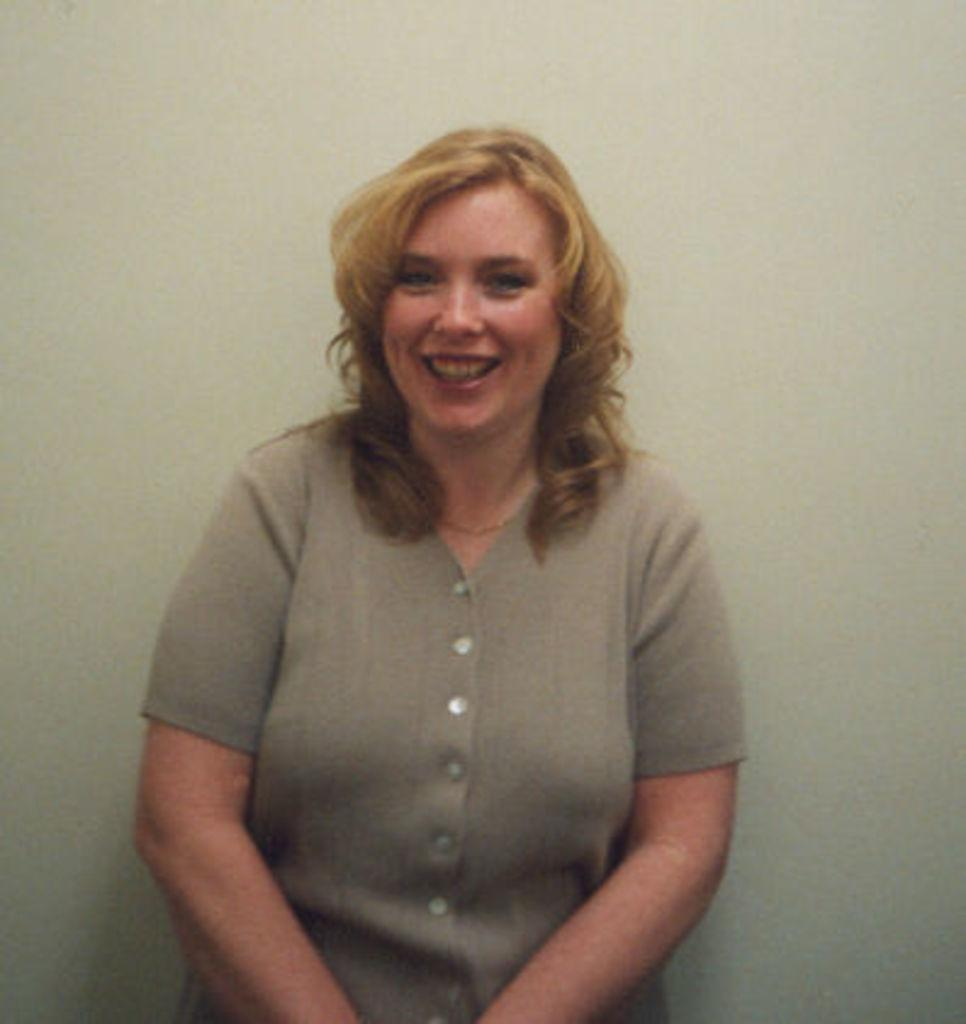Who is the main subject in the image? There is a woman in the image. What is the woman doing in the image? The woman is standing and giving a pose for the picture. What is the woman's facial expression in the image? The woman is smiling in the image. What can be seen in the background of the image? There is a wall in the background of the image. What type of advertisement can be seen on the wall in the image? There is no advertisement visible on the wall in the image. How many scales are present in the image? There are no scales present in the image. 